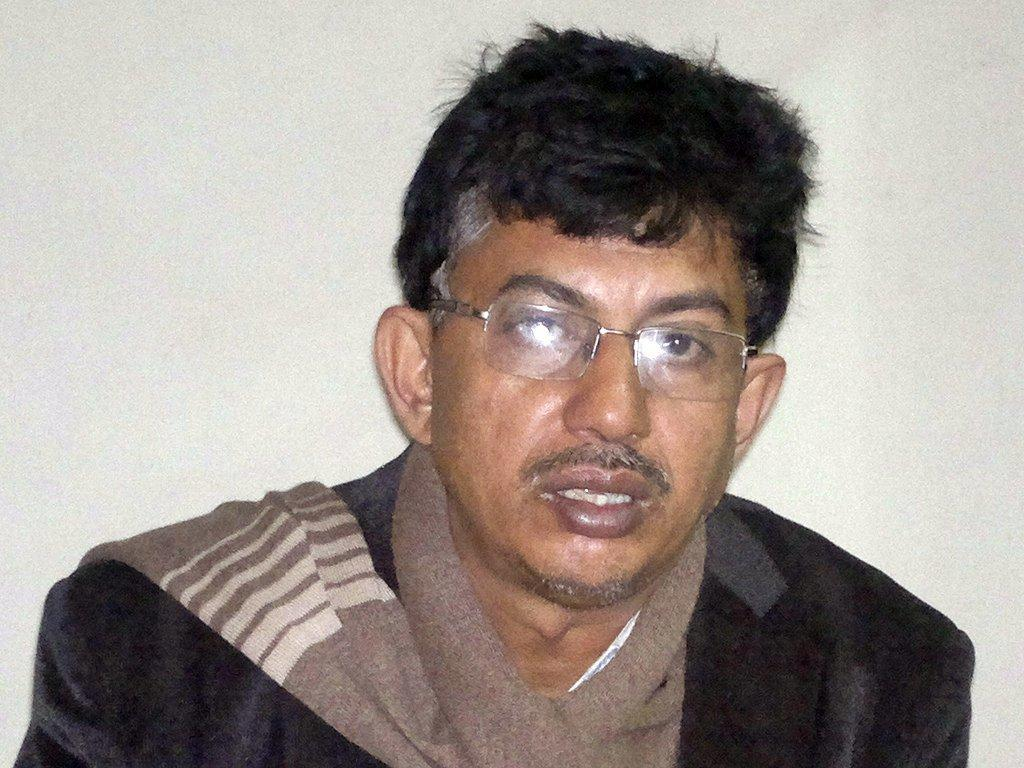Who is present in the image? There is a man in the image. What can be observed about the man's appearance? The man is wearing spectacles and clothes. What is the color of the background in the image? The background of the image is white. What type of game is the man playing in the image? There is no game present in the image; it only features a man wearing spectacles and clothes against a white background. What religious symbols can be seen in the image? There are no religious symbols present in the image. 